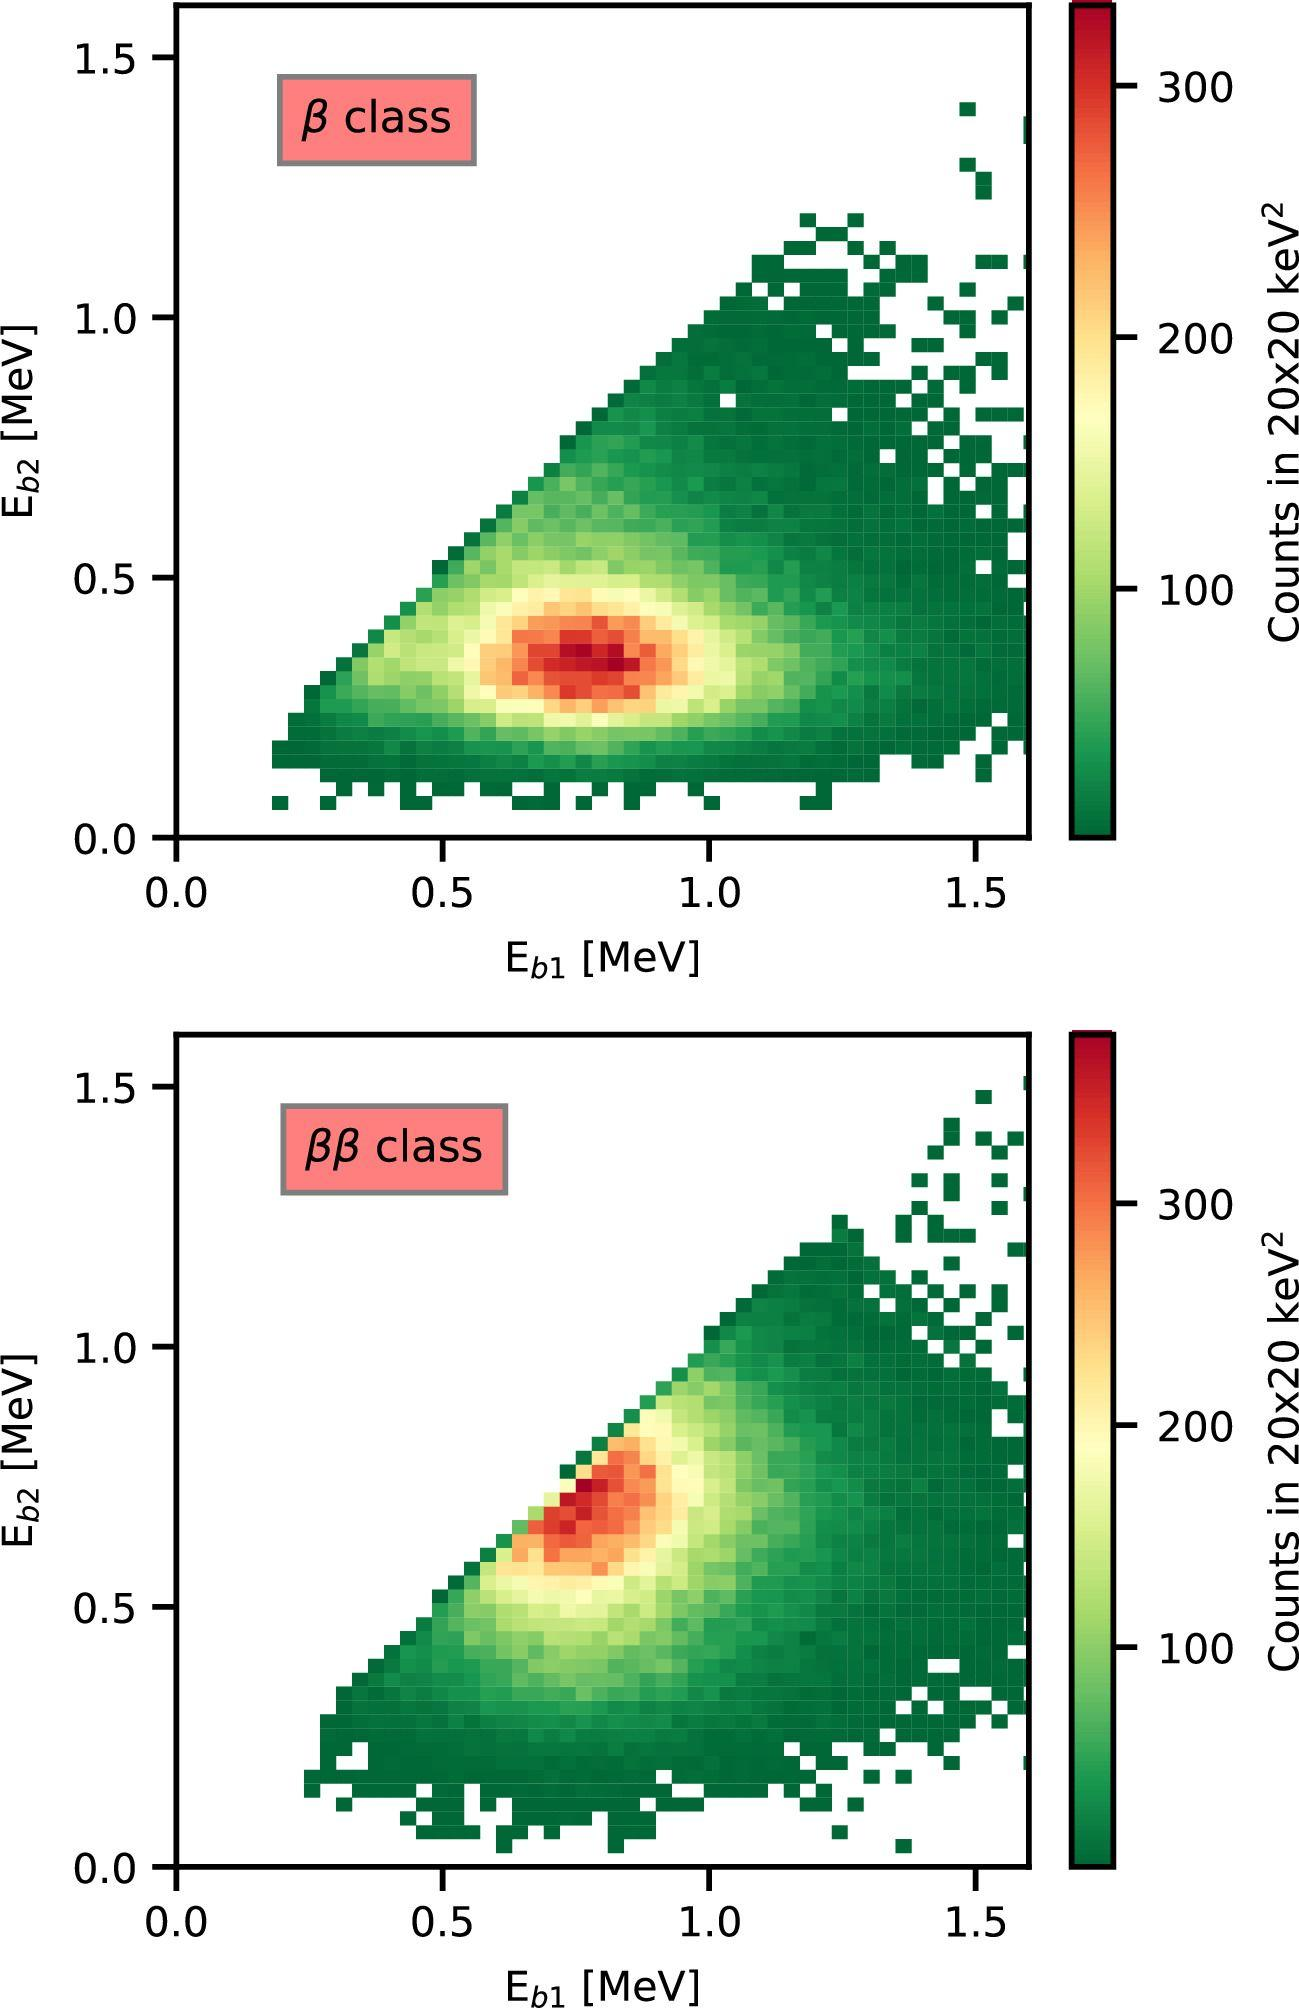What might the plots indicate about the physical phenomenon being observed? These plots are typical of what you might find in particle physics or nuclear experiments. The diagonal concentration suggests a strong linear correlation between the energies E_b1 and E_b2, which often indicates a conservation law being obeyed in a two-particle decay process. For example, in a beta decay event, you'd expect the sum of kinetic energies of the decay products to be consistent, hence the events cluster along the line of equal energies. The type of class-label ('beta' and 'double beta') further suggests these measurements relate to beta decay experiments, which are key in understanding properties like the mass of neutrinos or searching for rare events in physics. 